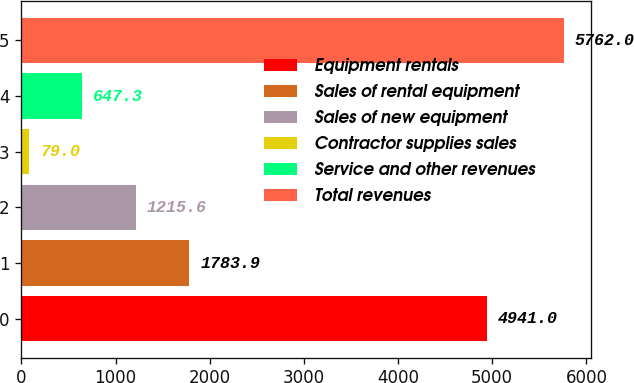Convert chart. <chart><loc_0><loc_0><loc_500><loc_500><bar_chart><fcel>Equipment rentals<fcel>Sales of rental equipment<fcel>Sales of new equipment<fcel>Contractor supplies sales<fcel>Service and other revenues<fcel>Total revenues<nl><fcel>4941<fcel>1783.9<fcel>1215.6<fcel>79<fcel>647.3<fcel>5762<nl></chart> 